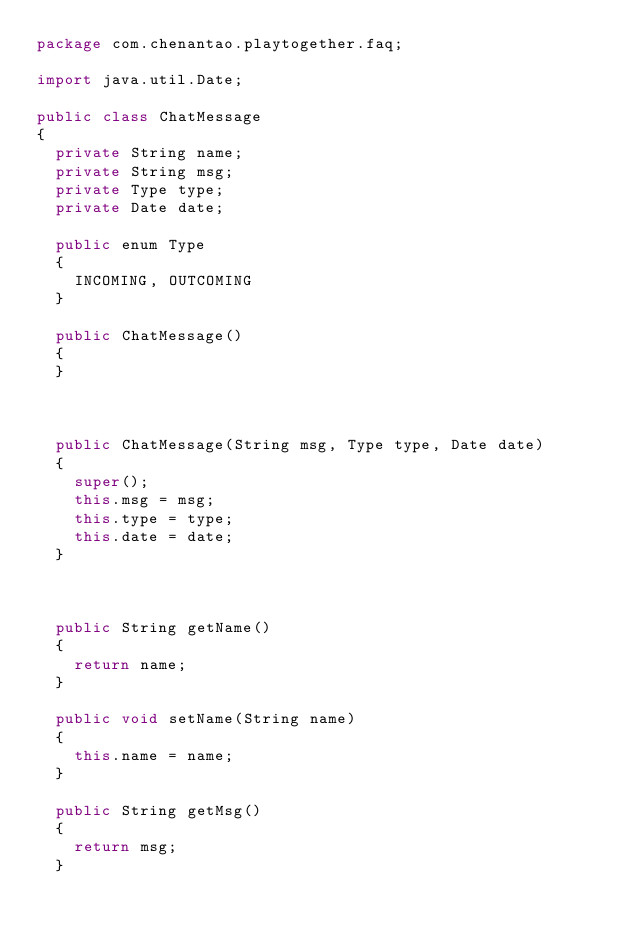Convert code to text. <code><loc_0><loc_0><loc_500><loc_500><_Java_>package com.chenantao.playtogether.faq;

import java.util.Date;

public class ChatMessage
{
	private String name;
	private String msg;
	private Type type;
	private Date date;

	public enum Type
	{
		INCOMING, OUTCOMING
	}
	
	public ChatMessage()
	{
	}
	
	

	public ChatMessage(String msg, Type type, Date date)
	{
		super();
		this.msg = msg;
		this.type = type;
		this.date = date;
	}



	public String getName()
	{
		return name;
	}

	public void setName(String name)
	{
		this.name = name;
	}

	public String getMsg()
	{
		return msg;
	}
</code> 